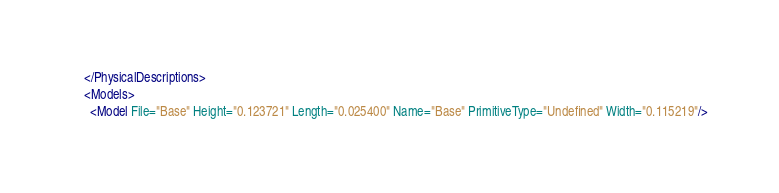Convert code to text. <code><loc_0><loc_0><loc_500><loc_500><_XML_>    </PhysicalDescriptions>
    <Models>
      <Model File="Base" Height="0.123721" Length="0.025400" Name="Base" PrimitiveType="Undefined" Width="0.115219"/></code> 